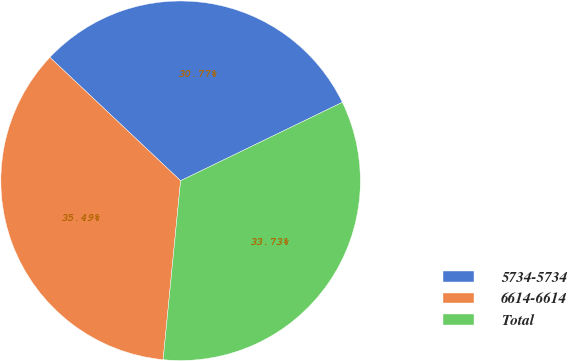<chart> <loc_0><loc_0><loc_500><loc_500><pie_chart><fcel>5734-5734<fcel>6614-6614<fcel>Total<nl><fcel>30.77%<fcel>35.49%<fcel>33.73%<nl></chart> 